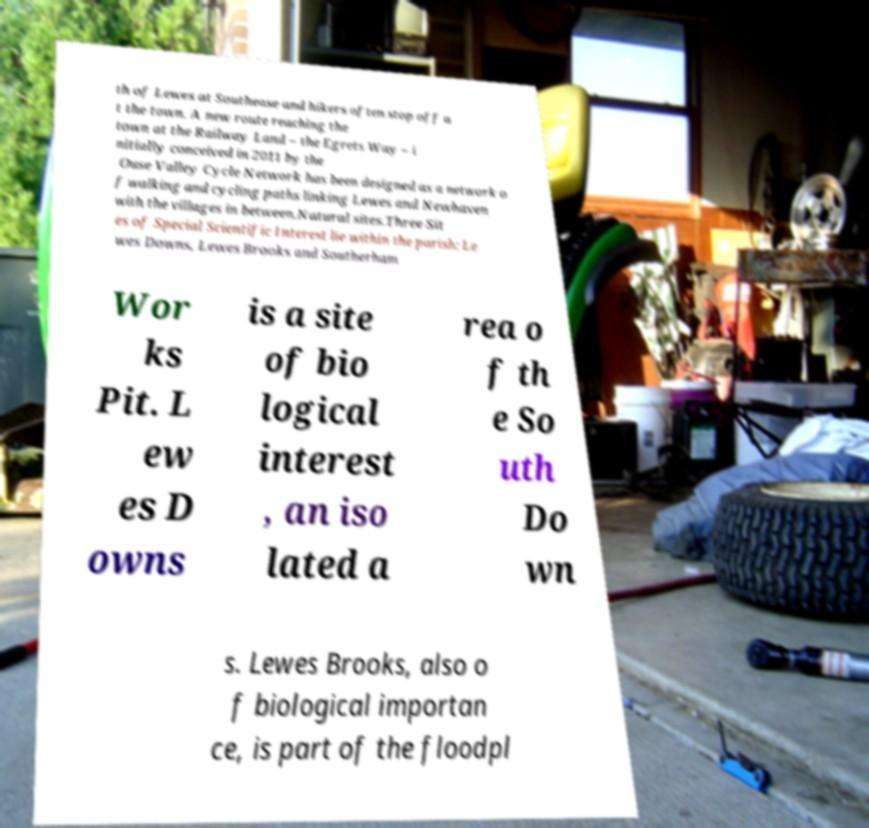What messages or text are displayed in this image? I need them in a readable, typed format. th of Lewes at Southease and hikers often stop off a t the town. A new route reaching the town at the Railway Land – the Egrets Way – i nitially conceived in 2011 by the Ouse Valley Cycle Network has been designed as a network o f walking and cycling paths linking Lewes and Newhaven with the villages in between.Natural sites.Three Sit es of Special Scientific Interest lie within the parish: Le wes Downs, Lewes Brooks and Southerham Wor ks Pit. L ew es D owns is a site of bio logical interest , an iso lated a rea o f th e So uth Do wn s. Lewes Brooks, also o f biological importan ce, is part of the floodpl 